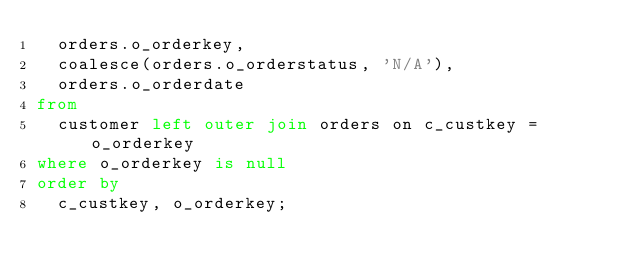<code> <loc_0><loc_0><loc_500><loc_500><_SQL_>  orders.o_orderkey,
  coalesce(orders.o_orderstatus, 'N/A'),
  orders.o_orderdate
from
  customer left outer join orders on c_custkey = o_orderkey
where o_orderkey is null
order by
  c_custkey, o_orderkey;</code> 